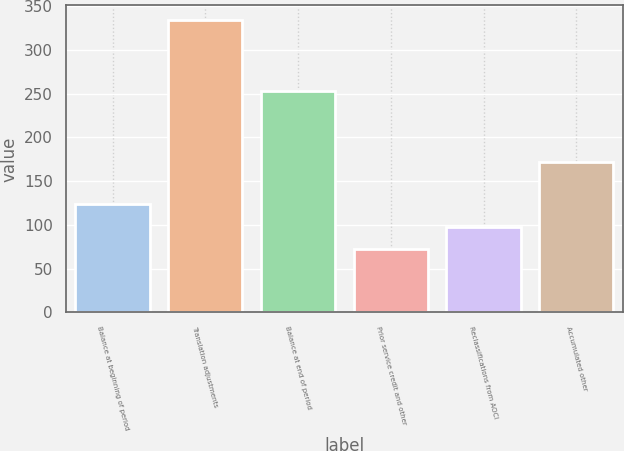Convert chart. <chart><loc_0><loc_0><loc_500><loc_500><bar_chart><fcel>Balance at beginning of period<fcel>Translation adjustments<fcel>Balance at end of period<fcel>Prior service credit and other<fcel>Reclassifications from AOCI<fcel>Accumulated other<nl><fcel>124.4<fcel>334<fcel>253<fcel>72<fcel>98.2<fcel>172<nl></chart> 